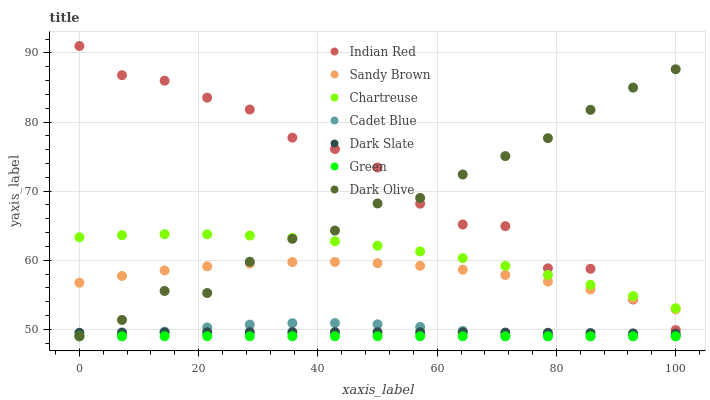Does Green have the minimum area under the curve?
Answer yes or no. Yes. Does Indian Red have the maximum area under the curve?
Answer yes or no. Yes. Does Dark Olive have the minimum area under the curve?
Answer yes or no. No. Does Dark Olive have the maximum area under the curve?
Answer yes or no. No. Is Green the smoothest?
Answer yes or no. Yes. Is Indian Red the roughest?
Answer yes or no. Yes. Is Dark Olive the smoothest?
Answer yes or no. No. Is Dark Olive the roughest?
Answer yes or no. No. Does Cadet Blue have the lowest value?
Answer yes or no. Yes. Does Dark Slate have the lowest value?
Answer yes or no. No. Does Indian Red have the highest value?
Answer yes or no. Yes. Does Dark Olive have the highest value?
Answer yes or no. No. Is Dark Slate less than Indian Red?
Answer yes or no. Yes. Is Sandy Brown greater than Dark Slate?
Answer yes or no. Yes. Does Dark Olive intersect Cadet Blue?
Answer yes or no. Yes. Is Dark Olive less than Cadet Blue?
Answer yes or no. No. Is Dark Olive greater than Cadet Blue?
Answer yes or no. No. Does Dark Slate intersect Indian Red?
Answer yes or no. No. 